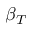<formula> <loc_0><loc_0><loc_500><loc_500>\beta _ { T }</formula> 